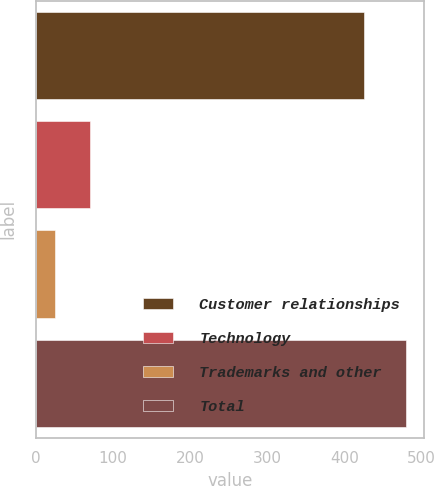Convert chart to OTSL. <chart><loc_0><loc_0><loc_500><loc_500><bar_chart><fcel>Customer relationships<fcel>Technology<fcel>Trademarks and other<fcel>Total<nl><fcel>426<fcel>70.5<fcel>25<fcel>480<nl></chart> 